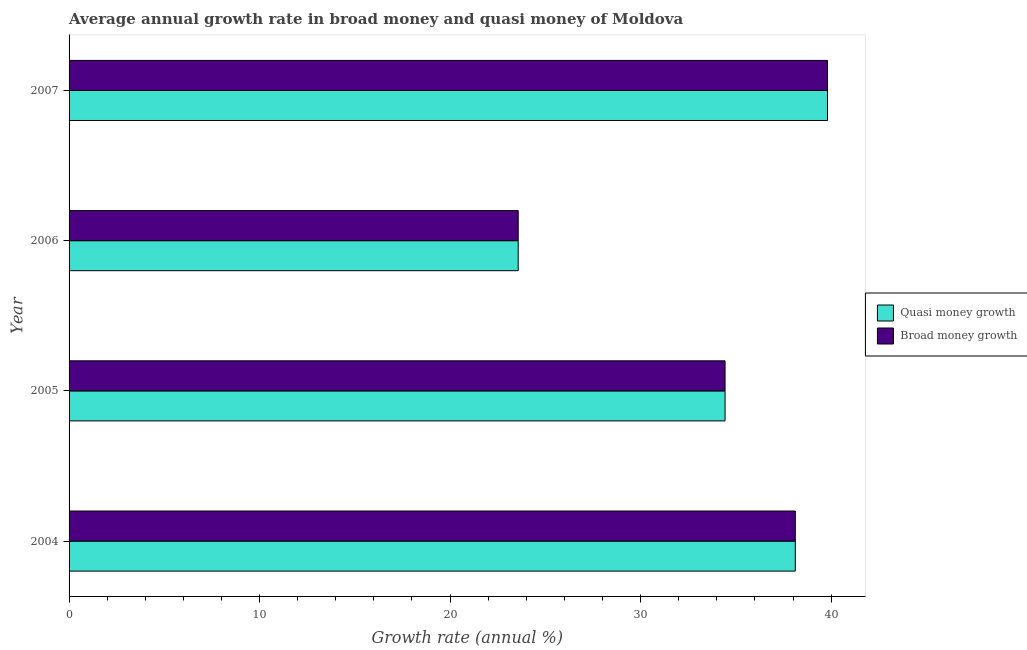How many different coloured bars are there?
Make the answer very short. 2. How many groups of bars are there?
Offer a terse response. 4. Are the number of bars on each tick of the Y-axis equal?
Provide a succinct answer. Yes. How many bars are there on the 3rd tick from the top?
Keep it short and to the point. 2. How many bars are there on the 2nd tick from the bottom?
Give a very brief answer. 2. What is the label of the 1st group of bars from the top?
Your response must be concise. 2007. What is the annual growth rate in quasi money in 2005?
Provide a short and direct response. 34.43. Across all years, what is the maximum annual growth rate in quasi money?
Make the answer very short. 39.81. Across all years, what is the minimum annual growth rate in quasi money?
Ensure brevity in your answer.  23.58. In which year was the annual growth rate in broad money maximum?
Your answer should be very brief. 2007. In which year was the annual growth rate in broad money minimum?
Offer a terse response. 2006. What is the total annual growth rate in quasi money in the graph?
Your response must be concise. 135.94. What is the difference between the annual growth rate in broad money in 2004 and that in 2006?
Provide a succinct answer. 14.54. What is the difference between the annual growth rate in broad money in 2006 and the annual growth rate in quasi money in 2007?
Offer a very short reply. -16.23. What is the average annual growth rate in quasi money per year?
Offer a very short reply. 33.98. In the year 2006, what is the difference between the annual growth rate in broad money and annual growth rate in quasi money?
Offer a terse response. 0. What is the ratio of the annual growth rate in quasi money in 2004 to that in 2006?
Your answer should be very brief. 1.62. Is the difference between the annual growth rate in quasi money in 2004 and 2006 greater than the difference between the annual growth rate in broad money in 2004 and 2006?
Offer a terse response. No. What is the difference between the highest and the second highest annual growth rate in broad money?
Keep it short and to the point. 1.69. What is the difference between the highest and the lowest annual growth rate in broad money?
Ensure brevity in your answer.  16.23. What does the 2nd bar from the top in 2007 represents?
Offer a terse response. Quasi money growth. What does the 1st bar from the bottom in 2006 represents?
Offer a terse response. Quasi money growth. How many bars are there?
Offer a very short reply. 8. How many years are there in the graph?
Your answer should be very brief. 4. What is the difference between two consecutive major ticks on the X-axis?
Your answer should be very brief. 10. Does the graph contain any zero values?
Give a very brief answer. No. How are the legend labels stacked?
Your answer should be very brief. Vertical. What is the title of the graph?
Provide a succinct answer. Average annual growth rate in broad money and quasi money of Moldova. Does "Rural Population" appear as one of the legend labels in the graph?
Give a very brief answer. No. What is the label or title of the X-axis?
Keep it short and to the point. Growth rate (annual %). What is the Growth rate (annual %) of Quasi money growth in 2004?
Ensure brevity in your answer.  38.12. What is the Growth rate (annual %) of Broad money growth in 2004?
Make the answer very short. 38.12. What is the Growth rate (annual %) in Quasi money growth in 2005?
Provide a succinct answer. 34.43. What is the Growth rate (annual %) in Broad money growth in 2005?
Offer a very short reply. 34.43. What is the Growth rate (annual %) in Quasi money growth in 2006?
Keep it short and to the point. 23.58. What is the Growth rate (annual %) in Broad money growth in 2006?
Your answer should be very brief. 23.58. What is the Growth rate (annual %) in Quasi money growth in 2007?
Your answer should be compact. 39.81. What is the Growth rate (annual %) of Broad money growth in 2007?
Your response must be concise. 39.81. Across all years, what is the maximum Growth rate (annual %) in Quasi money growth?
Make the answer very short. 39.81. Across all years, what is the maximum Growth rate (annual %) of Broad money growth?
Your answer should be compact. 39.81. Across all years, what is the minimum Growth rate (annual %) of Quasi money growth?
Provide a short and direct response. 23.58. Across all years, what is the minimum Growth rate (annual %) of Broad money growth?
Ensure brevity in your answer.  23.58. What is the total Growth rate (annual %) of Quasi money growth in the graph?
Your answer should be very brief. 135.94. What is the total Growth rate (annual %) of Broad money growth in the graph?
Your response must be concise. 135.94. What is the difference between the Growth rate (annual %) of Quasi money growth in 2004 and that in 2005?
Your answer should be compact. 3.69. What is the difference between the Growth rate (annual %) in Broad money growth in 2004 and that in 2005?
Your answer should be compact. 3.69. What is the difference between the Growth rate (annual %) in Quasi money growth in 2004 and that in 2006?
Provide a succinct answer. 14.55. What is the difference between the Growth rate (annual %) of Broad money growth in 2004 and that in 2006?
Provide a short and direct response. 14.55. What is the difference between the Growth rate (annual %) in Quasi money growth in 2004 and that in 2007?
Make the answer very short. -1.69. What is the difference between the Growth rate (annual %) of Broad money growth in 2004 and that in 2007?
Offer a terse response. -1.69. What is the difference between the Growth rate (annual %) in Quasi money growth in 2005 and that in 2006?
Make the answer very short. 10.86. What is the difference between the Growth rate (annual %) in Broad money growth in 2005 and that in 2006?
Your response must be concise. 10.86. What is the difference between the Growth rate (annual %) in Quasi money growth in 2005 and that in 2007?
Offer a terse response. -5.38. What is the difference between the Growth rate (annual %) in Broad money growth in 2005 and that in 2007?
Your answer should be compact. -5.38. What is the difference between the Growth rate (annual %) in Quasi money growth in 2006 and that in 2007?
Your response must be concise. -16.23. What is the difference between the Growth rate (annual %) of Broad money growth in 2006 and that in 2007?
Keep it short and to the point. -16.23. What is the difference between the Growth rate (annual %) of Quasi money growth in 2004 and the Growth rate (annual %) of Broad money growth in 2005?
Ensure brevity in your answer.  3.69. What is the difference between the Growth rate (annual %) in Quasi money growth in 2004 and the Growth rate (annual %) in Broad money growth in 2006?
Your answer should be very brief. 14.55. What is the difference between the Growth rate (annual %) of Quasi money growth in 2004 and the Growth rate (annual %) of Broad money growth in 2007?
Give a very brief answer. -1.69. What is the difference between the Growth rate (annual %) in Quasi money growth in 2005 and the Growth rate (annual %) in Broad money growth in 2006?
Offer a very short reply. 10.86. What is the difference between the Growth rate (annual %) of Quasi money growth in 2005 and the Growth rate (annual %) of Broad money growth in 2007?
Provide a short and direct response. -5.38. What is the difference between the Growth rate (annual %) in Quasi money growth in 2006 and the Growth rate (annual %) in Broad money growth in 2007?
Provide a short and direct response. -16.23. What is the average Growth rate (annual %) of Quasi money growth per year?
Offer a terse response. 33.99. What is the average Growth rate (annual %) in Broad money growth per year?
Make the answer very short. 33.99. What is the ratio of the Growth rate (annual %) of Quasi money growth in 2004 to that in 2005?
Give a very brief answer. 1.11. What is the ratio of the Growth rate (annual %) in Broad money growth in 2004 to that in 2005?
Offer a very short reply. 1.11. What is the ratio of the Growth rate (annual %) of Quasi money growth in 2004 to that in 2006?
Provide a short and direct response. 1.62. What is the ratio of the Growth rate (annual %) in Broad money growth in 2004 to that in 2006?
Keep it short and to the point. 1.62. What is the ratio of the Growth rate (annual %) in Quasi money growth in 2004 to that in 2007?
Make the answer very short. 0.96. What is the ratio of the Growth rate (annual %) of Broad money growth in 2004 to that in 2007?
Provide a succinct answer. 0.96. What is the ratio of the Growth rate (annual %) in Quasi money growth in 2005 to that in 2006?
Provide a short and direct response. 1.46. What is the ratio of the Growth rate (annual %) of Broad money growth in 2005 to that in 2006?
Your response must be concise. 1.46. What is the ratio of the Growth rate (annual %) of Quasi money growth in 2005 to that in 2007?
Make the answer very short. 0.86. What is the ratio of the Growth rate (annual %) of Broad money growth in 2005 to that in 2007?
Provide a succinct answer. 0.86. What is the ratio of the Growth rate (annual %) of Quasi money growth in 2006 to that in 2007?
Make the answer very short. 0.59. What is the ratio of the Growth rate (annual %) of Broad money growth in 2006 to that in 2007?
Your answer should be very brief. 0.59. What is the difference between the highest and the second highest Growth rate (annual %) of Quasi money growth?
Provide a succinct answer. 1.69. What is the difference between the highest and the second highest Growth rate (annual %) of Broad money growth?
Offer a very short reply. 1.69. What is the difference between the highest and the lowest Growth rate (annual %) of Quasi money growth?
Offer a very short reply. 16.23. What is the difference between the highest and the lowest Growth rate (annual %) in Broad money growth?
Ensure brevity in your answer.  16.23. 